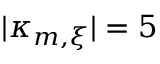Convert formula to latex. <formula><loc_0><loc_0><loc_500><loc_500>| \kappa _ { m , \xi } | = 5</formula> 